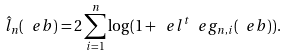<formula> <loc_0><loc_0><loc_500><loc_500>\hat { l } _ { n } ( \ e b ) = 2 \sum ^ { n } _ { i = 1 } \log ( 1 + \ e l ^ { t } \ e g _ { n , i } ( \ e b ) ) .</formula> 